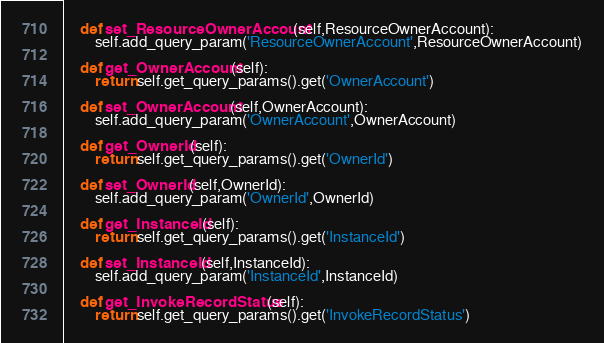<code> <loc_0><loc_0><loc_500><loc_500><_Python_>	def set_ResourceOwnerAccount(self,ResourceOwnerAccount):
		self.add_query_param('ResourceOwnerAccount',ResourceOwnerAccount)

	def get_OwnerAccount(self):
		return self.get_query_params().get('OwnerAccount')

	def set_OwnerAccount(self,OwnerAccount):
		self.add_query_param('OwnerAccount',OwnerAccount)

	def get_OwnerId(self):
		return self.get_query_params().get('OwnerId')

	def set_OwnerId(self,OwnerId):
		self.add_query_param('OwnerId',OwnerId)

	def get_InstanceId(self):
		return self.get_query_params().get('InstanceId')

	def set_InstanceId(self,InstanceId):
		self.add_query_param('InstanceId',InstanceId)

	def get_InvokeRecordStatus(self):
		return self.get_query_params().get('InvokeRecordStatus')</code> 